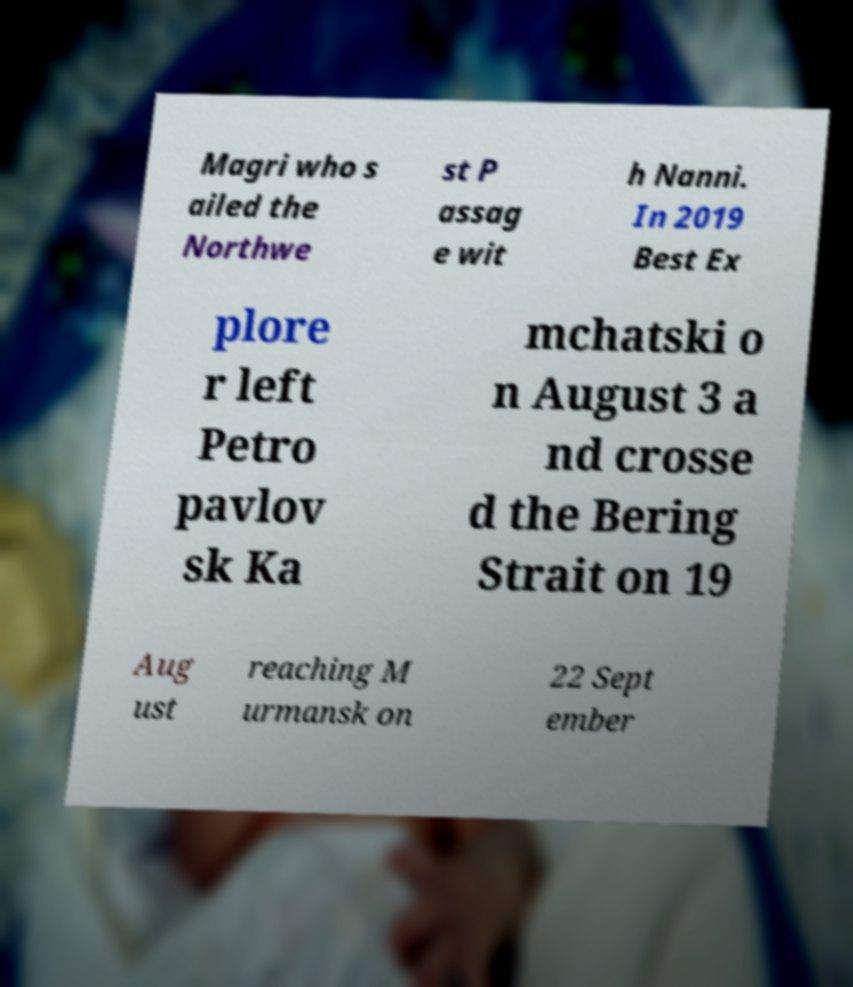Can you read and provide the text displayed in the image?This photo seems to have some interesting text. Can you extract and type it out for me? Magri who s ailed the Northwe st P assag e wit h Nanni. In 2019 Best Ex plore r left Petro pavlov sk Ka mchatski o n August 3 a nd crosse d the Bering Strait on 19 Aug ust reaching M urmansk on 22 Sept ember 